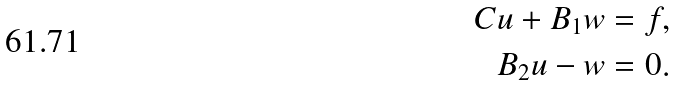<formula> <loc_0><loc_0><loc_500><loc_500>C u + B _ { 1 } w & = f , \\ B _ { 2 } u - w & = 0 .</formula> 